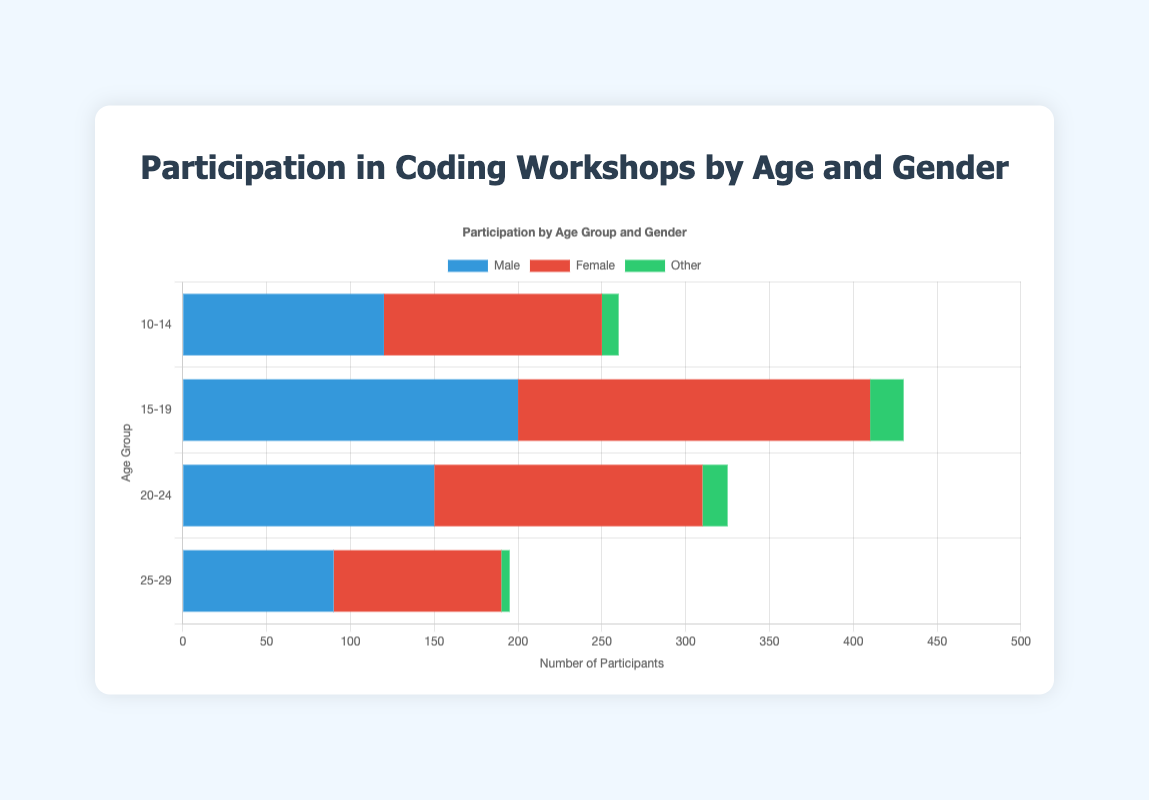Which age group has the highest total participation across all genders? To find the age group with the highest total participation, sum the participants of each gender within each age group. For "10-14" it's (120 + 130 + 10) = 260. For "15-19" it's (200 + 210 + 20) = 430. For "20-24" it's (150 + 160 + 15) = 325. For "25-29" it's (90 + 100 + 5) = 195. The age group with the highest total participation is "15-19" with 430 participants.
Answer: 15-19 Which gender had the lowest participation in the "20-24" age group? Look at the "20-24" age group and compare the number of participants for each gender. Male has 150, Female has 160, and Other has 15 participants. The gender with the lowest participation is "Other".
Answer: Other How many more participants are there in the "10-14" age group compared to the "25-29" age group? First, sum the total participants for each age group. "10-14" has 260 participants, and "25-29" has 195 participants. Then, subtract the total participants of "25-29" from "10-14" (260 - 195).
Answer: 65 Which gender had the highest participation overall? Sum the participants of each gender across all age groups. Male: 120 + 200 + 150 + 90 = 560, Female: 130 + 210 + 160 + 100 = 600, Other: 10 + 20 + 15 + 5 = 50. The gender with the highest participation overall is "Female" with 600 participants.
Answer: Female In the "15-19" age group, how many more female participants were there than male participants? Look at the participants of "15-19" age group for Male and Female. Male has 200 participants and Female has 210 participants. Subtract the number of Male participants from Female (210 - 200).
Answer: 10 What is the total number of participants who identify as "Other" across all age groups? Sum the number of participants who identify as "Other" across all age groups: 10 + 20 + 15 + 5 = 50.
Answer: 50 Which age group has more male participants, the "10-14" age group or the "25-29" age group? Compare the male participants in both groups. "10-14" has 120 and "25-29" has 90. "10-14" has more male participants.
Answer: 10-14 Among the "25-29" age group, which gender has the second-highest participation? Compare the number of participants for each gender in the "25-29" age group. Male has 90, Female has 100, and Other has 5. The second-highest participation is Male with 90 participants.
Answer: Male What is the average number of participants in the "20-24" age group across all genders? Sum the participants in the "20-24" age group (150 + 160 + 15) and divide by the number of genders (3). (150 + 160 + 15) / 3 = 325 / 3 = roughly 108.33.
Answer: ~108.33 